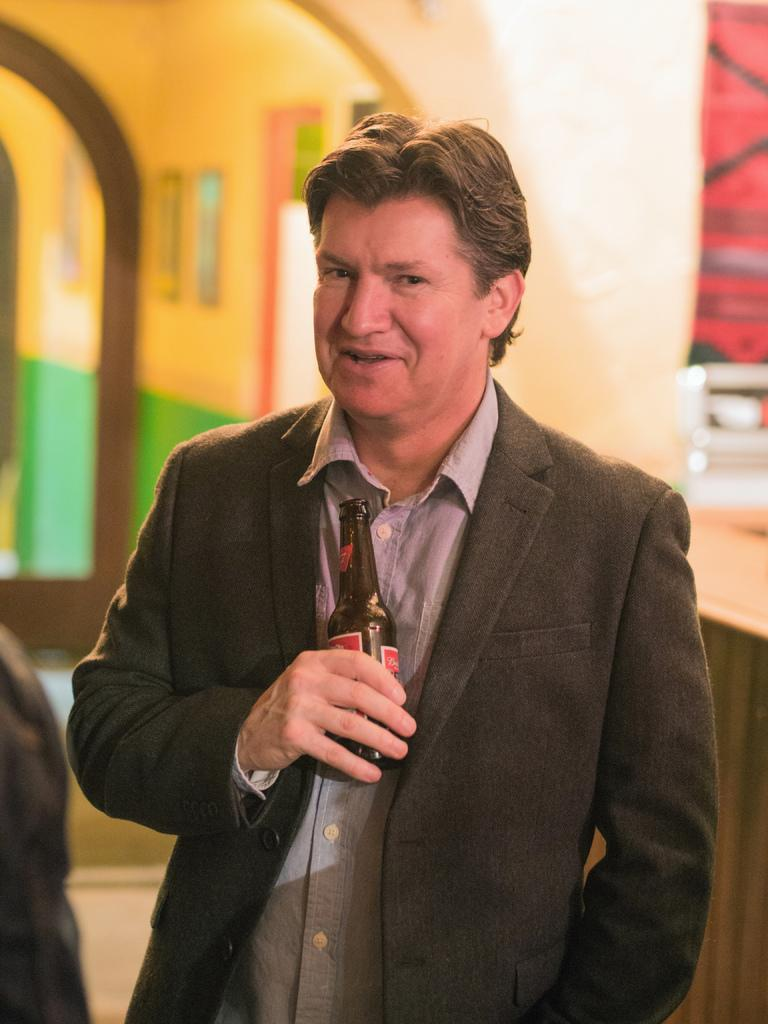What is the main subject of the image? The main subject of the image is a person standing. What is the person holding in his hand? The person is holding a bottle in his hand. Can you tell me how many family members are visible in the image? There is no reference to family members in the image; it only features a person standing and holding a bottle. What route is the crow flying in the image? There is no crow present in the image. 